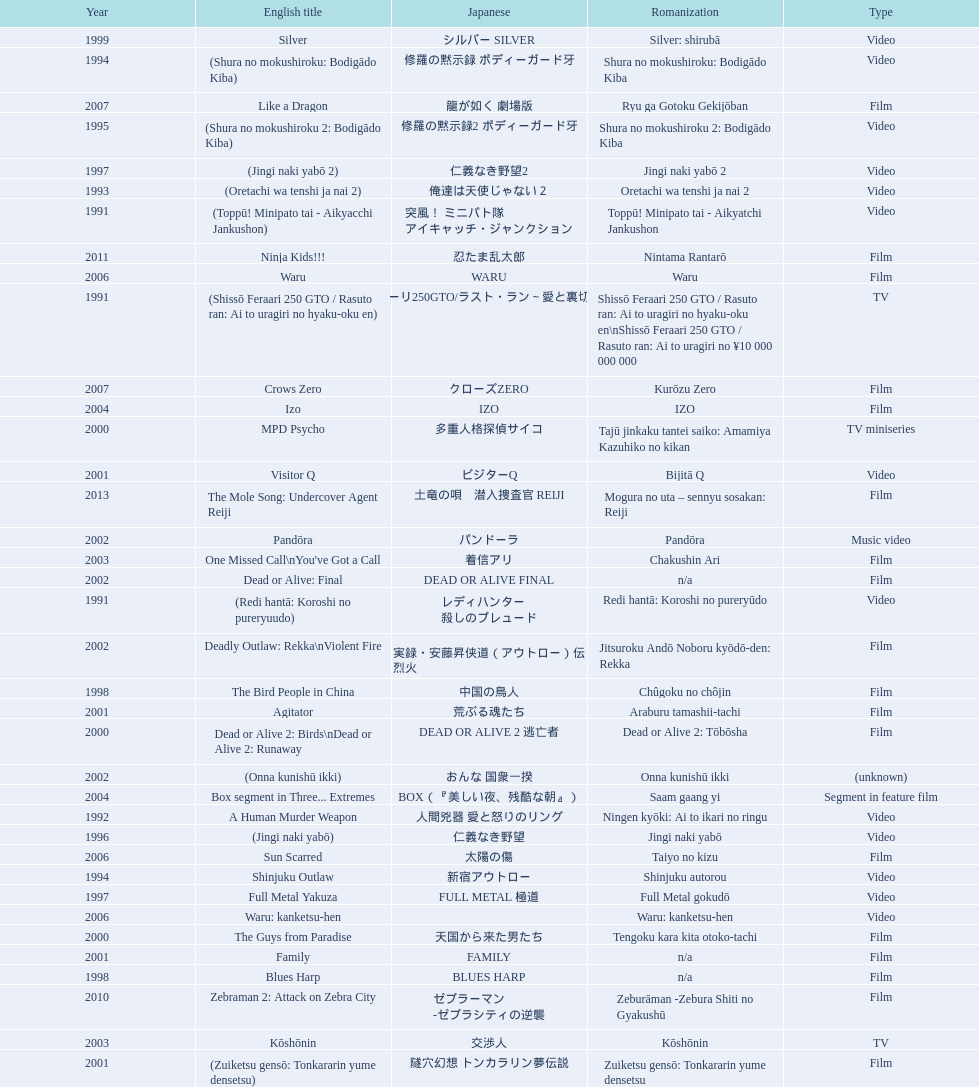Which title is listed next after "the way to fight"? Fudoh: The New Generation. 